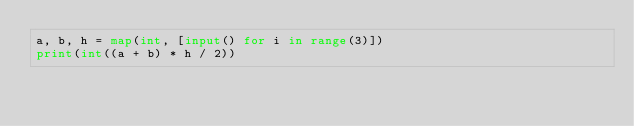Convert code to text. <code><loc_0><loc_0><loc_500><loc_500><_Python_>a, b, h = map(int, [input() for i in range(3)])
print(int((a + b) * h / 2))
</code> 